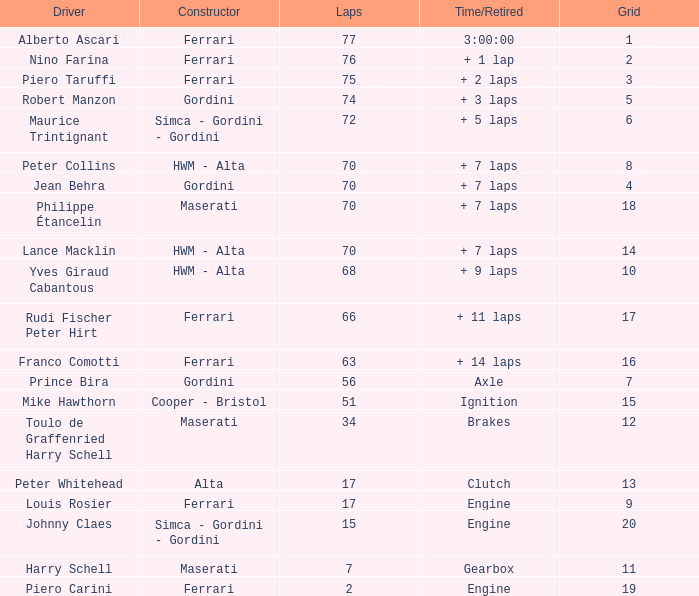What is the high grid for ferrari's with 2 laps? 19.0. 